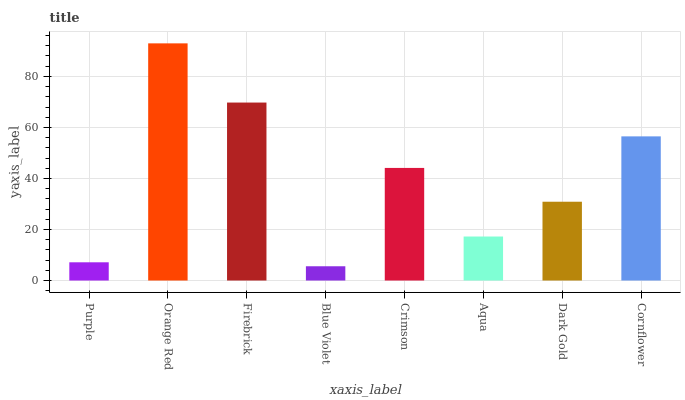Is Blue Violet the minimum?
Answer yes or no. Yes. Is Orange Red the maximum?
Answer yes or no. Yes. Is Firebrick the minimum?
Answer yes or no. No. Is Firebrick the maximum?
Answer yes or no. No. Is Orange Red greater than Firebrick?
Answer yes or no. Yes. Is Firebrick less than Orange Red?
Answer yes or no. Yes. Is Firebrick greater than Orange Red?
Answer yes or no. No. Is Orange Red less than Firebrick?
Answer yes or no. No. Is Crimson the high median?
Answer yes or no. Yes. Is Dark Gold the low median?
Answer yes or no. Yes. Is Blue Violet the high median?
Answer yes or no. No. Is Crimson the low median?
Answer yes or no. No. 